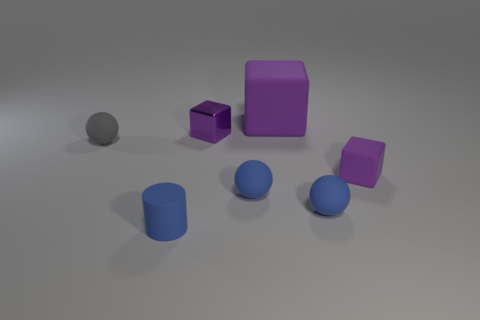Are the object to the left of the blue cylinder and the small ball to the right of the large purple rubber cube made of the same material?
Your answer should be very brief. Yes. How many blue rubber cylinders are the same size as the gray sphere?
Your answer should be very brief. 1. Are there fewer blue objects than large purple metallic cubes?
Offer a very short reply. No. What shape is the rubber object that is behind the tiny rubber ball that is left of the small matte cylinder?
Your answer should be compact. Cube. The gray rubber thing that is the same size as the purple metal cube is what shape?
Provide a succinct answer. Sphere. Are there any other small matte objects of the same shape as the tiny gray object?
Provide a succinct answer. Yes. What material is the big object?
Keep it short and to the point. Rubber. Are there any gray matte spheres behind the rubber cylinder?
Give a very brief answer. Yes. How many purple objects are to the left of the rubber object that is behind the metal thing?
Make the answer very short. 1. What material is the gray thing that is the same size as the metallic block?
Keep it short and to the point. Rubber. 